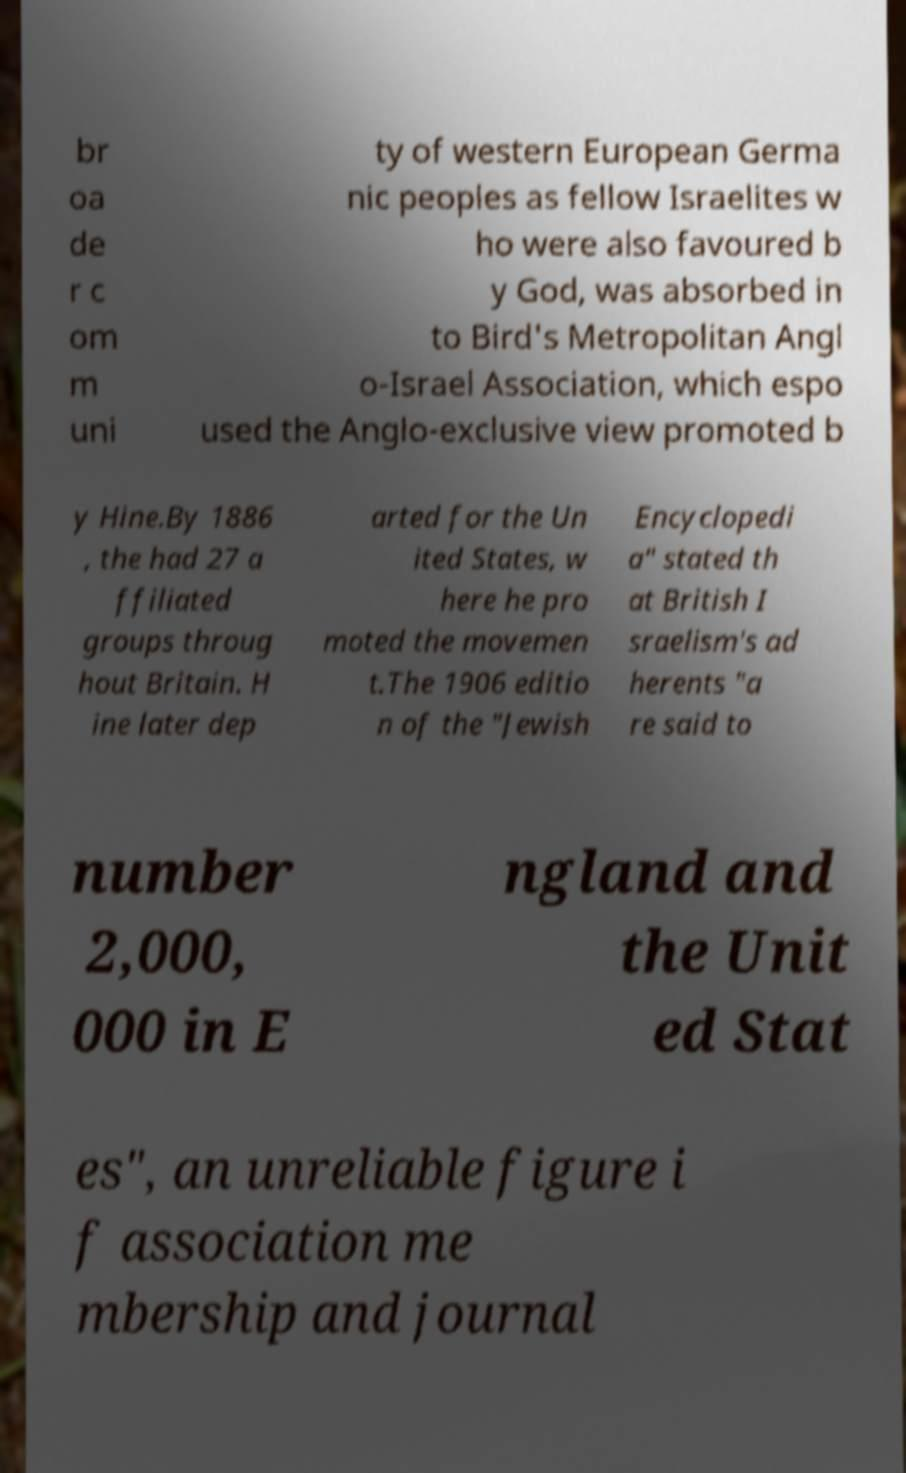Could you assist in decoding the text presented in this image and type it out clearly? br oa de r c om m uni ty of western European Germa nic peoples as fellow Israelites w ho were also favoured b y God, was absorbed in to Bird's Metropolitan Angl o-Israel Association, which espo used the Anglo-exclusive view promoted b y Hine.By 1886 , the had 27 a ffiliated groups throug hout Britain. H ine later dep arted for the Un ited States, w here he pro moted the movemen t.The 1906 editio n of the "Jewish Encyclopedi a" stated th at British I sraelism's ad herents "a re said to number 2,000, 000 in E ngland and the Unit ed Stat es", an unreliable figure i f association me mbership and journal 